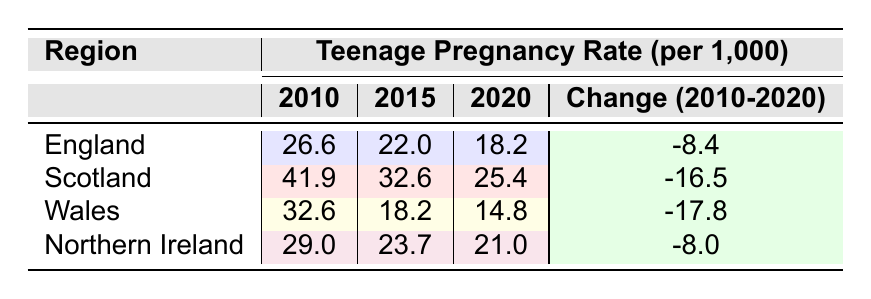What was the teenage pregnancy rate in England in 2010? The table shows that the rate for England in 2010 is specified directly as 26.6 per 1,000.
Answer: 26.6 What was the change in the teenage pregnancy rate in Wales from 2010 to 2020? The rate for Wales in 2010 was 32.6 and in 2020 it was 14.8. To find the change, we subtract 14.8 from 32.6: 32.6 - 14.8 = 17.8. Therefore, the change is a decrease of 17.8.
Answer: 17.8 Is the teenage pregnancy rate in Scotland lower than in Northern Ireland in 2015? In 2015, Scotland's rate was 32.6 and Northern Ireland's was 23.7. Since 32.6 is greater than 23.7, the statement is false.
Answer: No What region had the highest teenage pregnancy rate in 2020? Looking at the table for the year 2020, we see that Scotland's rate was 25.4, which is the highest compared to the other regions (England 18.2, Wales 14.8, Northern Ireland 21.0), making Scotland the region with the highest rate in that year.
Answer: Scotland What is the average teenage pregnancy rate in England from 2010 to 2020? The rates for England over the years are 26.6 (2010), 22.0 (2015), and 18.2 (2020). To find the average, we add these rates: 26.6 + 22.0 + 18.2 = 66.8. Then we divide by the number of years (3): 66.8 / 3 = 22.27, which is approximately 22.3 when rounded to one decimal place.
Answer: 22.3 